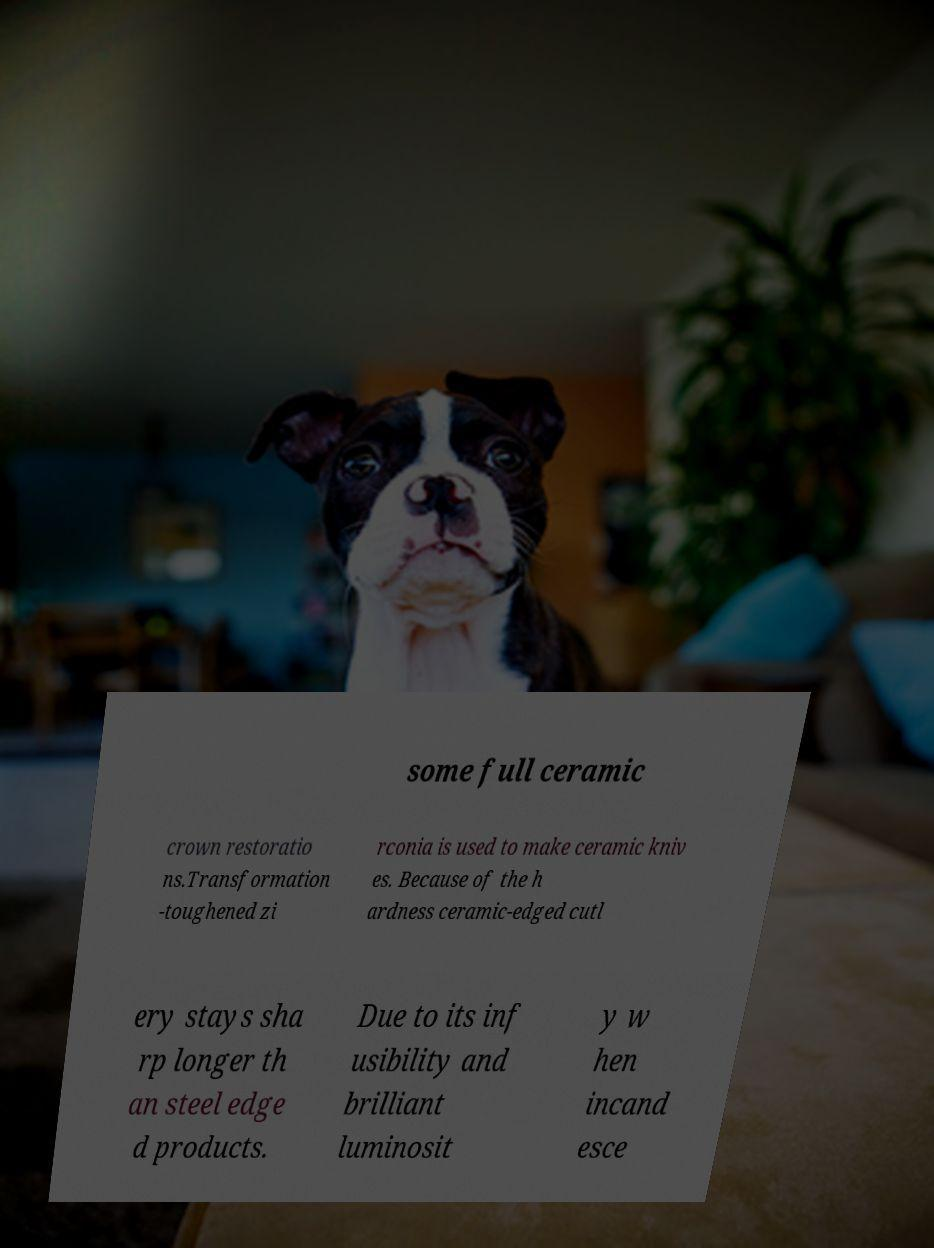Can you accurately transcribe the text from the provided image for me? some full ceramic crown restoratio ns.Transformation -toughened zi rconia is used to make ceramic kniv es. Because of the h ardness ceramic-edged cutl ery stays sha rp longer th an steel edge d products. Due to its inf usibility and brilliant luminosit y w hen incand esce 